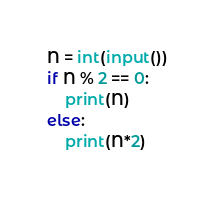Convert code to text. <code><loc_0><loc_0><loc_500><loc_500><_Python_>N = int(input())
if N % 2 == 0:
    print(N)
else:
    print(N*2)</code> 